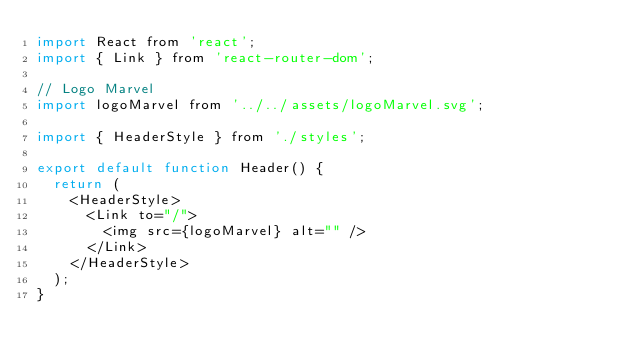Convert code to text. <code><loc_0><loc_0><loc_500><loc_500><_JavaScript_>import React from 'react';
import { Link } from 'react-router-dom';

// Logo Marvel
import logoMarvel from '../../assets/logoMarvel.svg';

import { HeaderStyle } from './styles';

export default function Header() {
  return (
    <HeaderStyle>
      <Link to="/">
        <img src={logoMarvel} alt="" />
      </Link>
    </HeaderStyle>
  );
}
</code> 